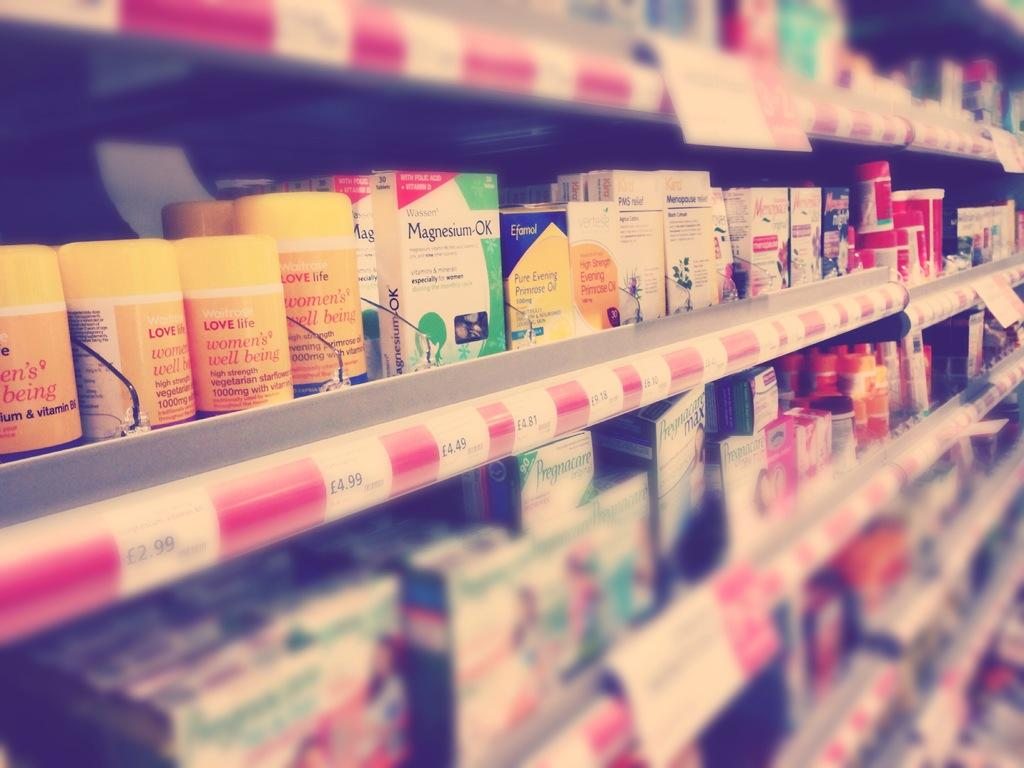<image>
Summarize the visual content of the image. A store shelf containing vitamins, minerals, and Magnesium-Ok. 